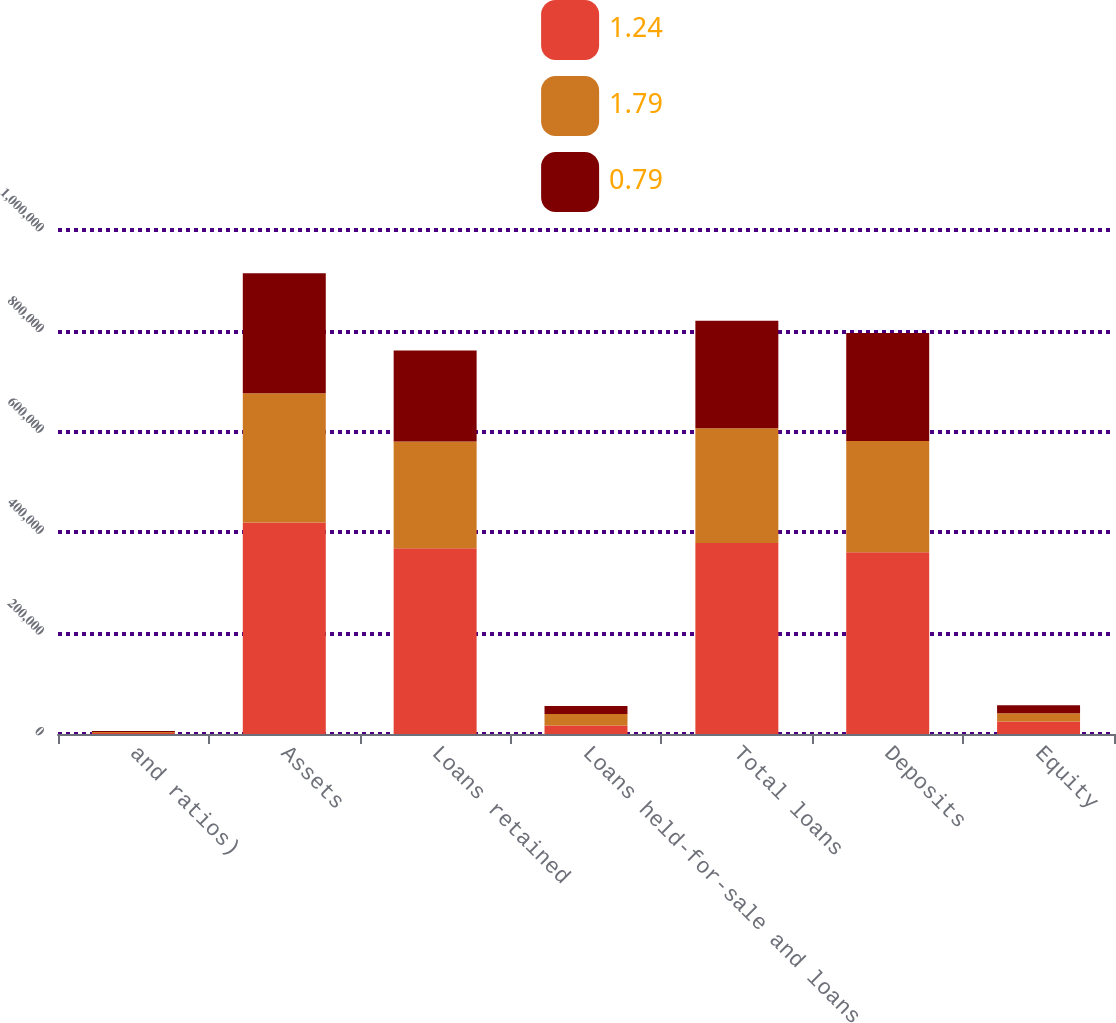Convert chart. <chart><loc_0><loc_0><loc_500><loc_500><stacked_bar_chart><ecel><fcel>and ratios)<fcel>Assets<fcel>Loans retained<fcel>Loans held-for-sale and loans<fcel>Total loans<fcel>Deposits<fcel>Equity<nl><fcel>1.24<fcel>2008<fcel>419831<fcel>368786<fcel>17056<fcel>378782<fcel>360451<fcel>25000<nl><fcel>1.79<fcel>2007<fcel>256351<fcel>211324<fcel>22587<fcel>227865<fcel>221129<fcel>16000<nl><fcel>0.79<fcel>2006<fcel>237887<fcel>180760<fcel>16129<fcel>213504<fcel>214081<fcel>16000<nl></chart> 